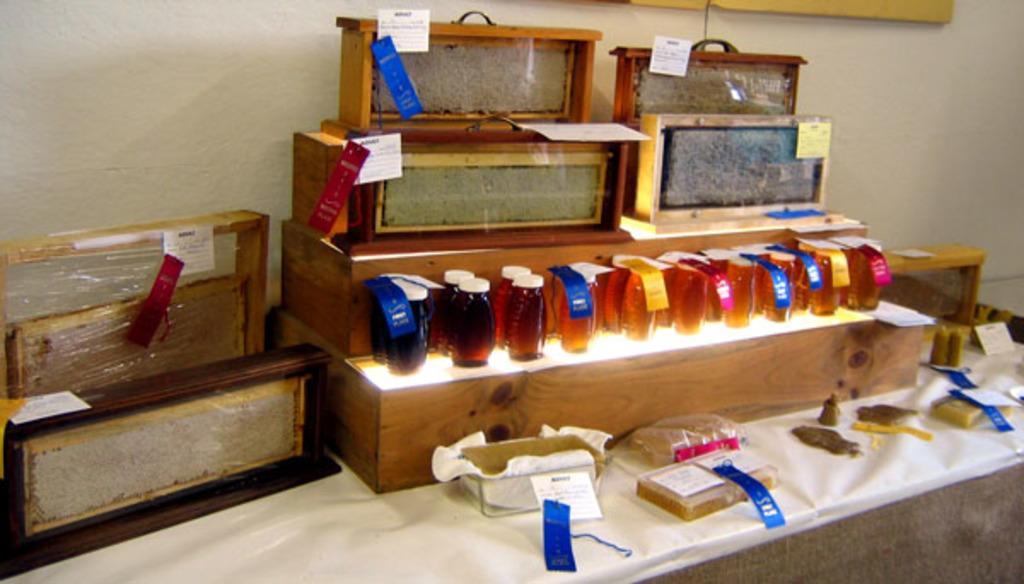In one or two sentences, can you explain what this image depicts? This looks like a table, which is covered with a cloth. I can see the wooden boxes and bottles with the tags attached to it are placed on the table. This is the wall. 